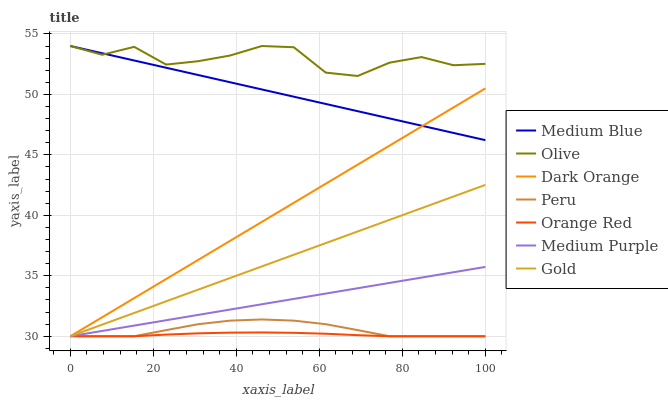Does Orange Red have the minimum area under the curve?
Answer yes or no. Yes. Does Olive have the maximum area under the curve?
Answer yes or no. Yes. Does Gold have the minimum area under the curve?
Answer yes or no. No. Does Gold have the maximum area under the curve?
Answer yes or no. No. Is Dark Orange the smoothest?
Answer yes or no. Yes. Is Olive the roughest?
Answer yes or no. Yes. Is Gold the smoothest?
Answer yes or no. No. Is Gold the roughest?
Answer yes or no. No. Does Dark Orange have the lowest value?
Answer yes or no. Yes. Does Medium Blue have the lowest value?
Answer yes or no. No. Does Olive have the highest value?
Answer yes or no. Yes. Does Gold have the highest value?
Answer yes or no. No. Is Gold less than Medium Blue?
Answer yes or no. Yes. Is Olive greater than Medium Purple?
Answer yes or no. Yes. Does Medium Blue intersect Dark Orange?
Answer yes or no. Yes. Is Medium Blue less than Dark Orange?
Answer yes or no. No. Is Medium Blue greater than Dark Orange?
Answer yes or no. No. Does Gold intersect Medium Blue?
Answer yes or no. No. 